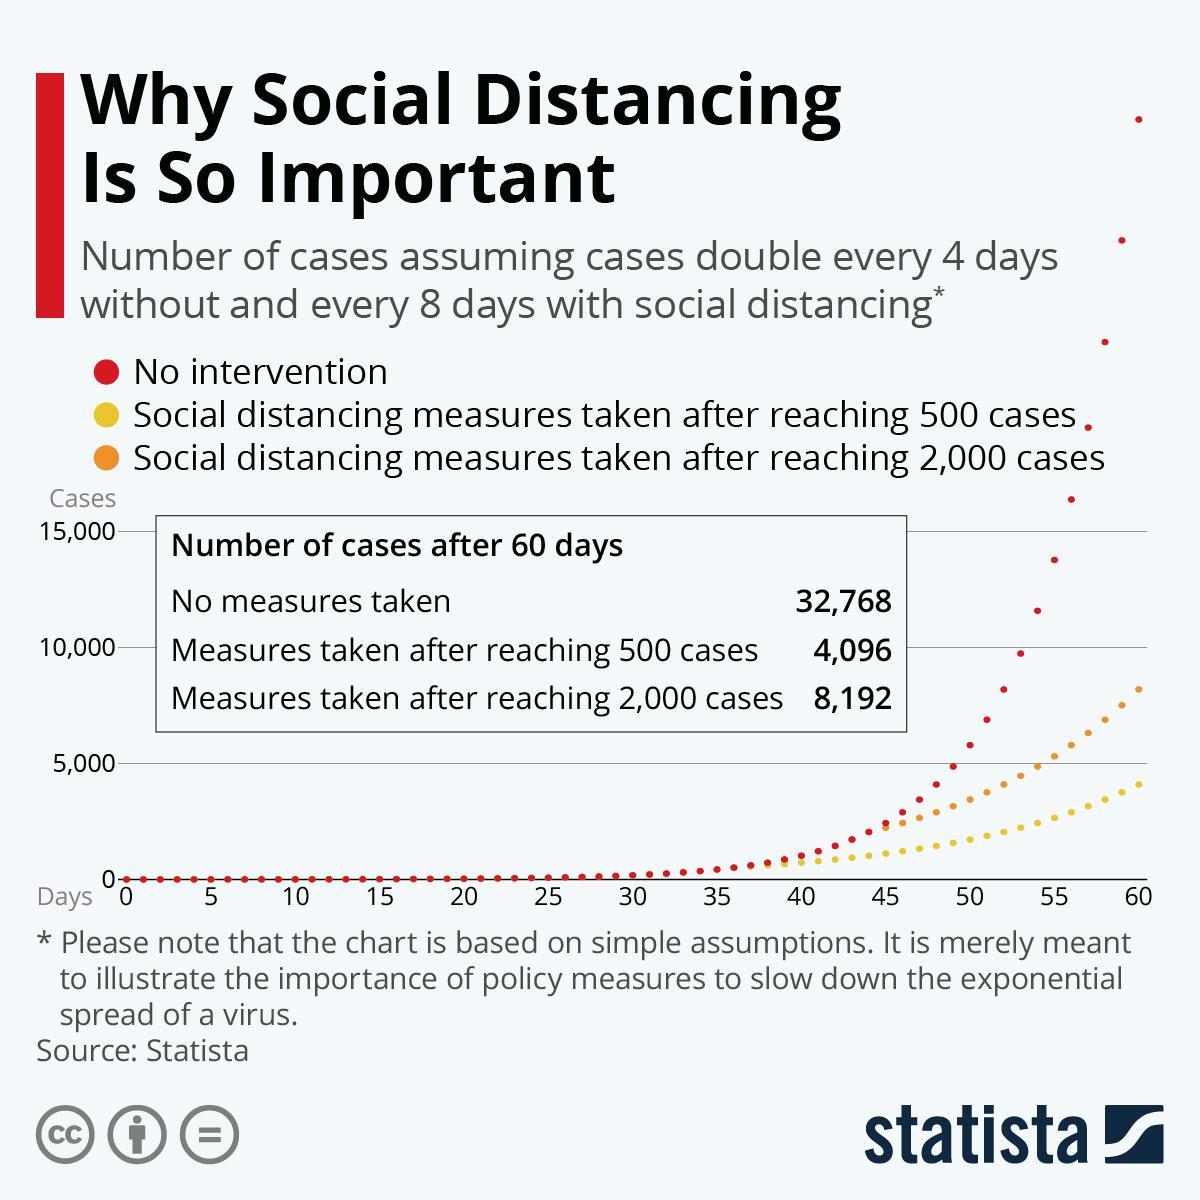What is the difference in number of cases after 60 days if measures are taken after 500 and 2000 cases?
Answer the question with a short phrase. 4,096 Above how many cases will the total number of cases increase if there is no intervention? 15,000 Which parameter is shown using yellow colour on the graph? Social distancing measures taken after reaching 500 cases Which parameter is shown using red colour on the graph? No intervention 